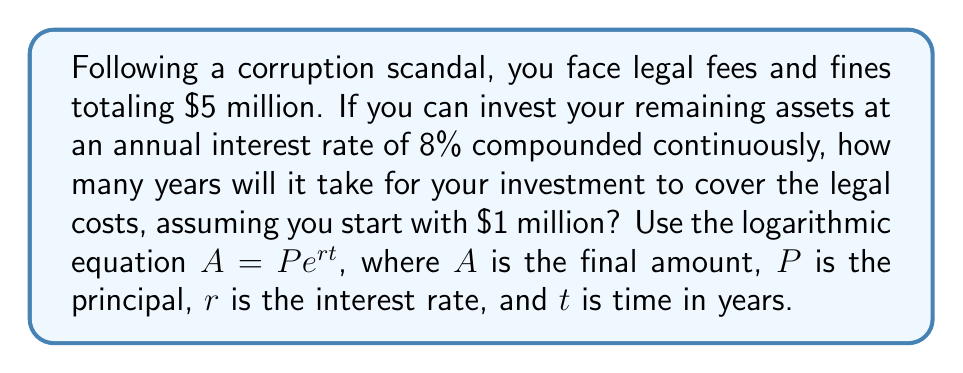Solve this math problem. Let's approach this step-by-step:

1) We're using the continuous compound interest formula:
   $A = Pe^{rt}$

2) We know:
   $A = \$5,000,000$ (the amount we need to reach)
   $P = \$1,000,000$ (the initial investment)
   $r = 0.08$ (8% annual interest rate)
   We need to solve for $t$ (time in years)

3) Let's substitute these values into the equation:
   $5,000,000 = 1,000,000e^{0.08t}$

4) Divide both sides by 1,000,000:
   $5 = e^{0.08t}$

5) Take the natural log of both sides:
   $\ln(5) = \ln(e^{0.08t})$

6) Simplify the right side using the property of logarithms:
   $\ln(5) = 0.08t$

7) Solve for $t$:
   $t = \frac{\ln(5)}{0.08}$

8) Calculate:
   $t = \frac{1.6094...}{0.08} \approx 20.1175$

Therefore, it will take approximately 20.12 years for the investment to grow to cover the legal costs.
Answer: $20.12$ years 